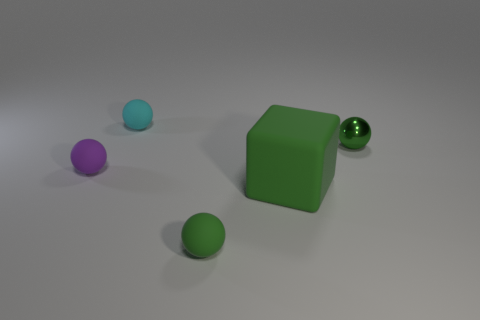What number of other things are there of the same size as the rubber cube?
Your answer should be very brief. 0. There is a tiny green object that is made of the same material as the big green object; what shape is it?
Offer a very short reply. Sphere. Are there any small things that have the same color as the large thing?
Your response must be concise. Yes. How many matte things are spheres or small green spheres?
Ensure brevity in your answer.  3. How many matte spheres are on the left side of the green matte object in front of the large green rubber block?
Keep it short and to the point. 2. How many objects have the same material as the large cube?
Offer a very short reply. 3. How many tiny objects are either cyan objects or purple blocks?
Provide a succinct answer. 1. There is a thing that is both behind the purple object and on the left side of the green metal thing; what is its shape?
Ensure brevity in your answer.  Sphere. What is the color of the shiny thing that is the same size as the cyan rubber object?
Make the answer very short. Green. There is a thing that is both behind the big green matte thing and to the right of the tiny green matte thing; what color is it?
Offer a terse response. Green. 